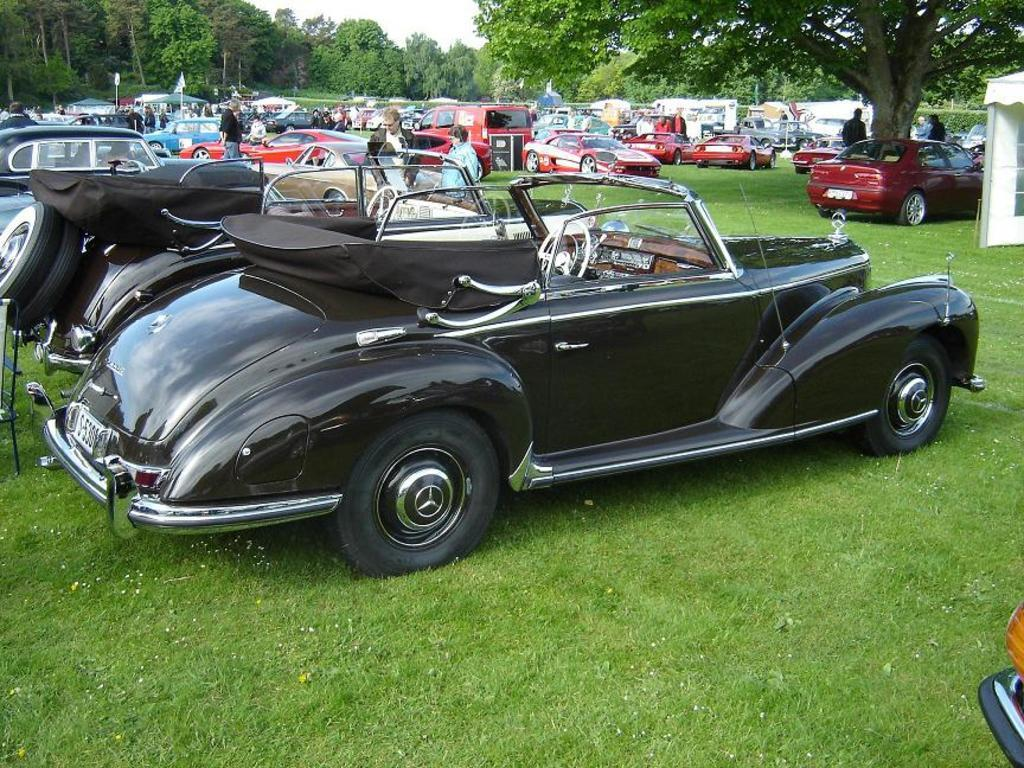What can be seen parked on the ground in the image? There are cars parked on the ground in the image. What type of surface is the ground covered with? The ground is covered with grass. Are there any people present in the image? Yes, there are people standing on the ground. What can be seen in the distance in the image? There are trees visible in the background of the image. What type of company is represented by the zebra in the image? There is no zebra present in the image, so it is not possible to determine what type of company it might represent. 